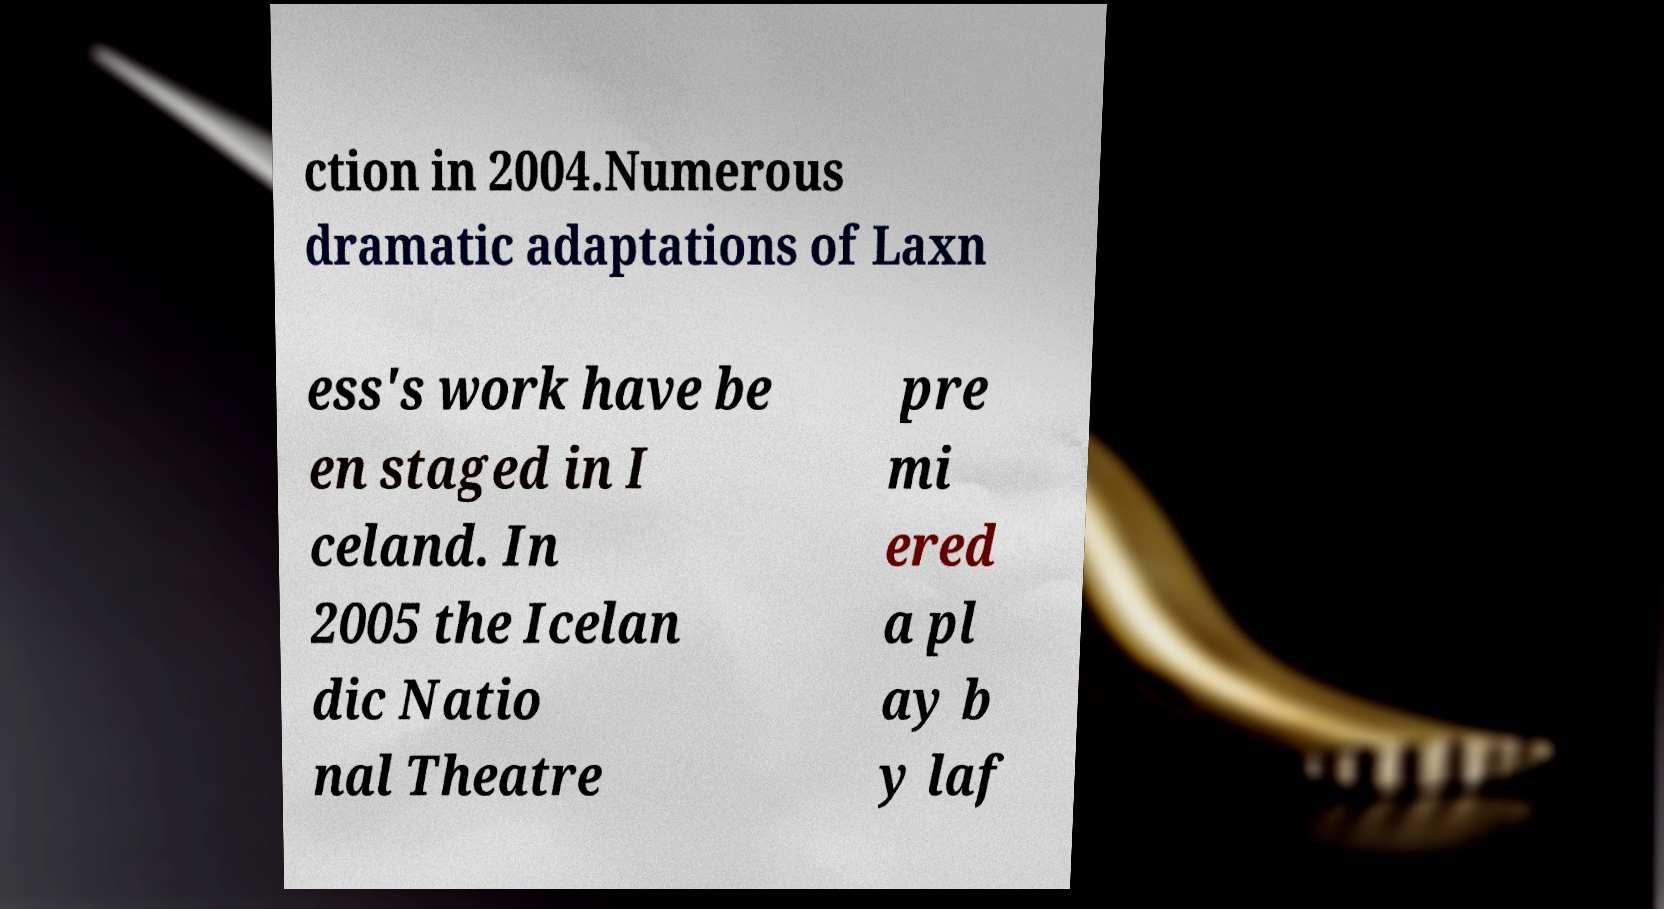What messages or text are displayed in this image? I need them in a readable, typed format. ction in 2004.Numerous dramatic adaptations of Laxn ess's work have be en staged in I celand. In 2005 the Icelan dic Natio nal Theatre pre mi ered a pl ay b y laf 